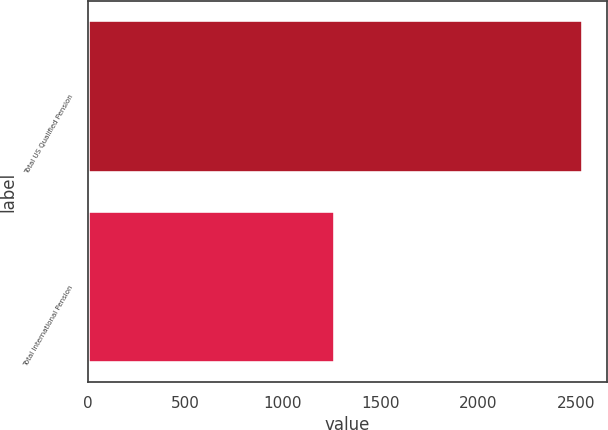Convert chart to OTSL. <chart><loc_0><loc_0><loc_500><loc_500><bar_chart><fcel>Total US Qualified Pension<fcel>Total International Pension<nl><fcel>2534.2<fcel>1266.6<nl></chart> 